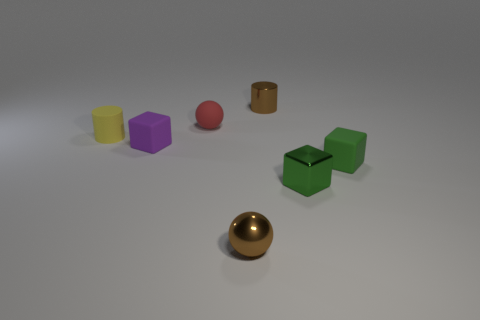Can you describe the scene depicted in the image in detail? Certainly! The image displays an assortment of geometric objects arranged on what appears to be a flat surface. From left to right, there's a yellow cylinder, purple cube, red sphere, tiny brown cylinder, a golden sphere, and two green cubes. The lighting suggests an indoor environment with a rather neutral background, emphasizing the objects.  Which object stands out the most and why? The golden sphere stands out due to its reflective metallic surface which contrasts significantly with the matte textures of the other objects. Its position in the center also draws the viewer's eye, making it a focal point of the composition. 